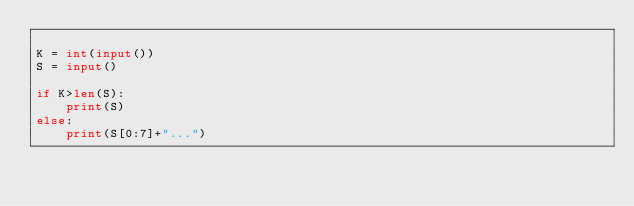Convert code to text. <code><loc_0><loc_0><loc_500><loc_500><_Python_>
K = int(input())
S = input()

if K>len(S):
    print(S)
else:
    print(S[0:7]+"...")
</code> 